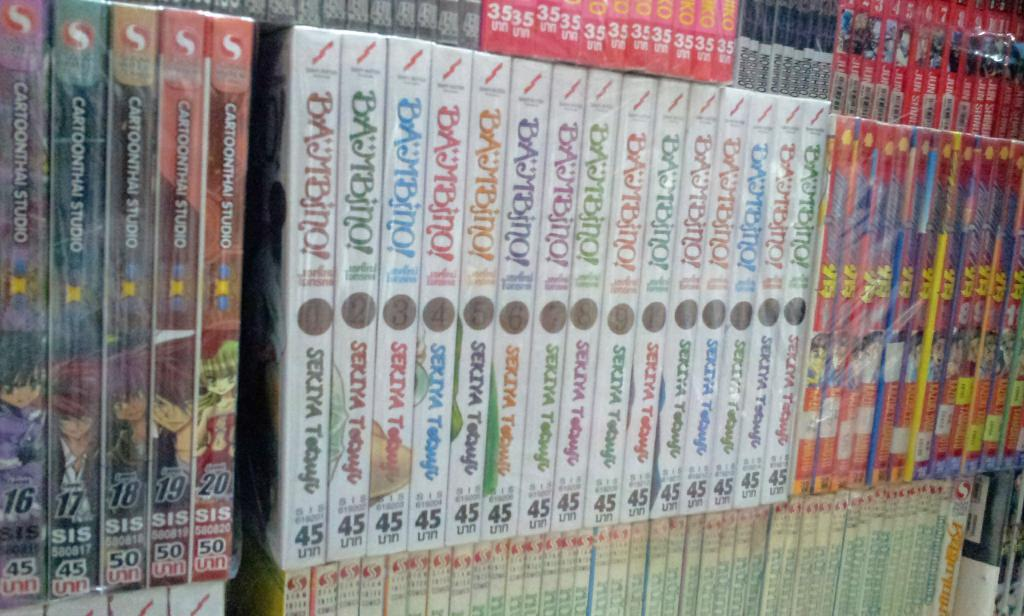<image>
Summarize the visual content of the image. A series of books are on a shelf with the number 45 on the binding. 